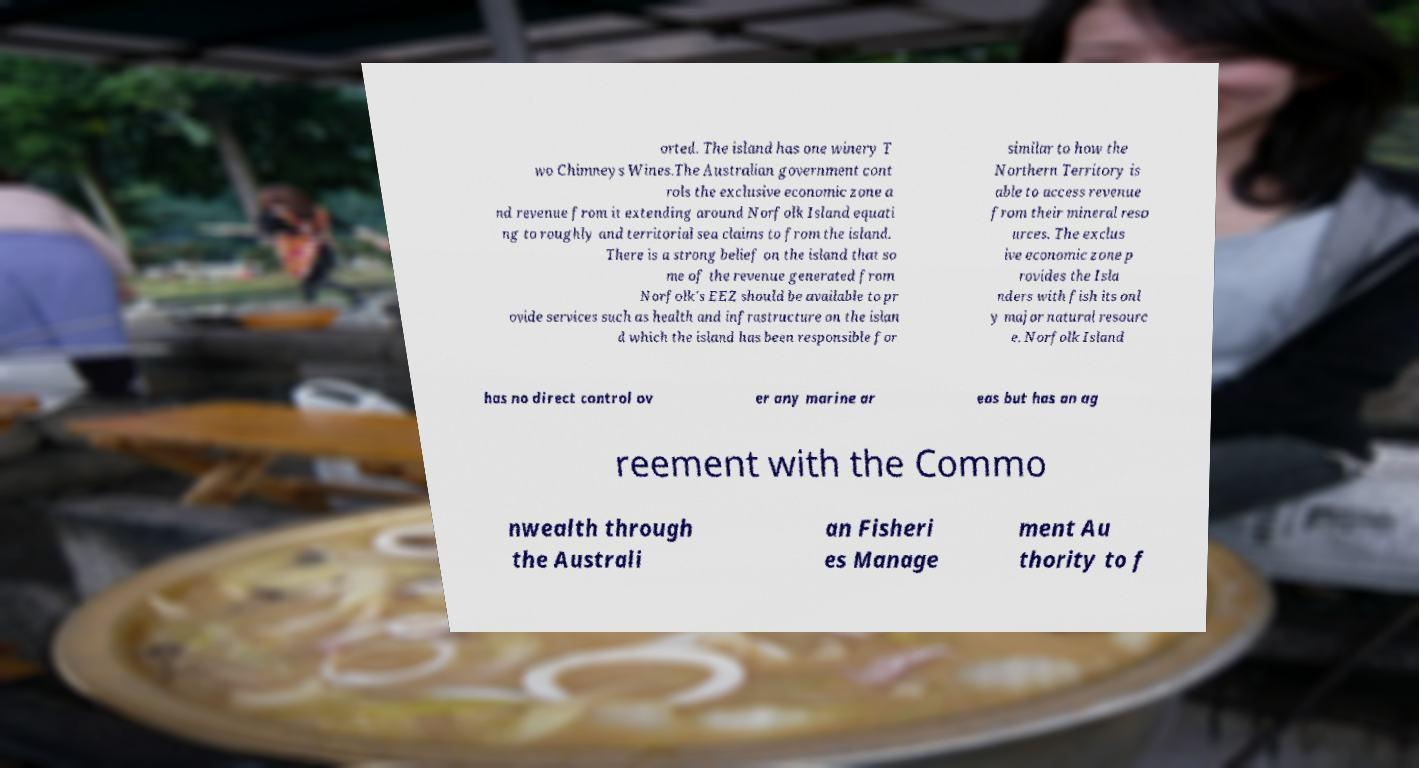Could you assist in decoding the text presented in this image and type it out clearly? orted. The island has one winery T wo Chimneys Wines.The Australian government cont rols the exclusive economic zone a nd revenue from it extending around Norfolk Island equati ng to roughly and territorial sea claims to from the island. There is a strong belief on the island that so me of the revenue generated from Norfolk's EEZ should be available to pr ovide services such as health and infrastructure on the islan d which the island has been responsible for similar to how the Northern Territory is able to access revenue from their mineral reso urces. The exclus ive economic zone p rovides the Isla nders with fish its onl y major natural resourc e. Norfolk Island has no direct control ov er any marine ar eas but has an ag reement with the Commo nwealth through the Australi an Fisheri es Manage ment Au thority to f 